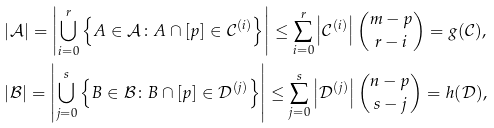<formula> <loc_0><loc_0><loc_500><loc_500>& | \mathcal { A } | = \left | \bigcup _ { i = 0 } ^ { r } \left \{ A \in \mathcal { A } \colon A \cap [ p ] \in \mathcal { C } ^ { ( i ) } \right \} \right | \leq \sum _ { i = 0 } ^ { r } \left | \mathcal { C } ^ { ( i ) } \right | { m - p \choose r - i } = g ( \mathcal { C } ) , \\ & | \mathcal { B } | = \left | \bigcup _ { j = 0 } ^ { s } \left \{ B \in \mathcal { B } \colon B \cap [ p ] \in \mathcal { D } ^ { ( j ) } \right \} \right | \leq \sum _ { j = 0 } ^ { s } \left | \mathcal { D } ^ { ( j ) } \right | { n - p \choose s - j } = h ( \mathcal { D } ) ,</formula> 